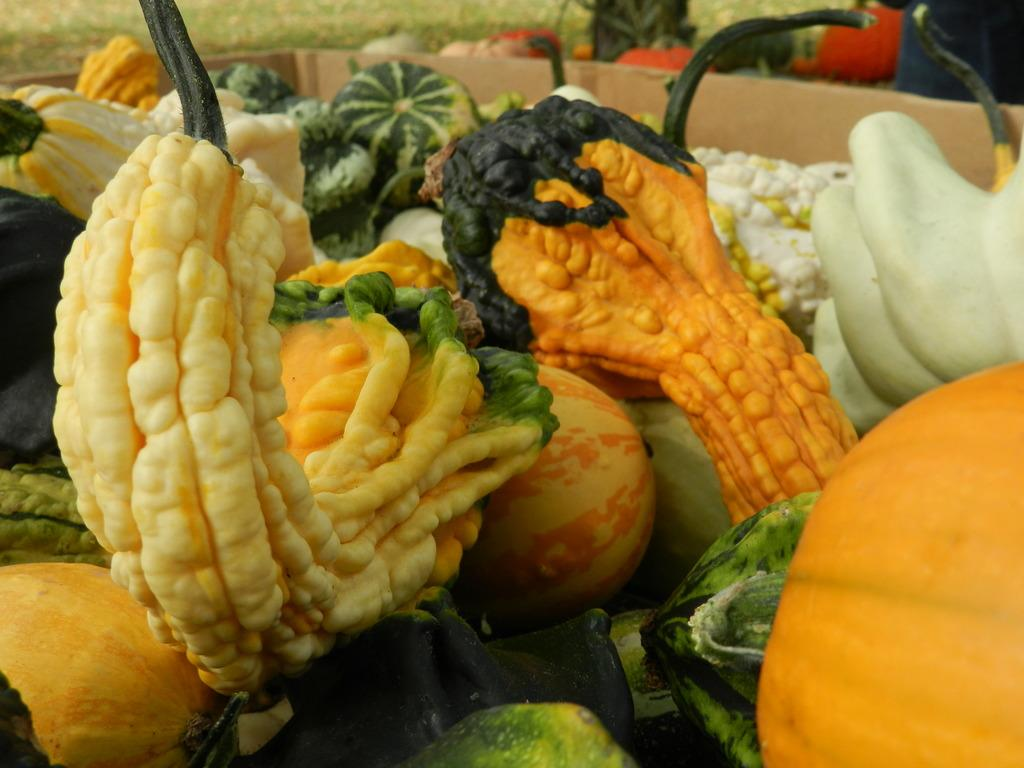What types of food items are present in the image? There are vegetables and fruits in the image. How are the fruits and vegetables arranged in the image? The fruits and vegetables are in a box. Can you describe the background of the image? The background of the image is blurred. What type of pickle can be seen on the floor in the image? There is no pickle present in the image, and the floor is not visible in the image. 